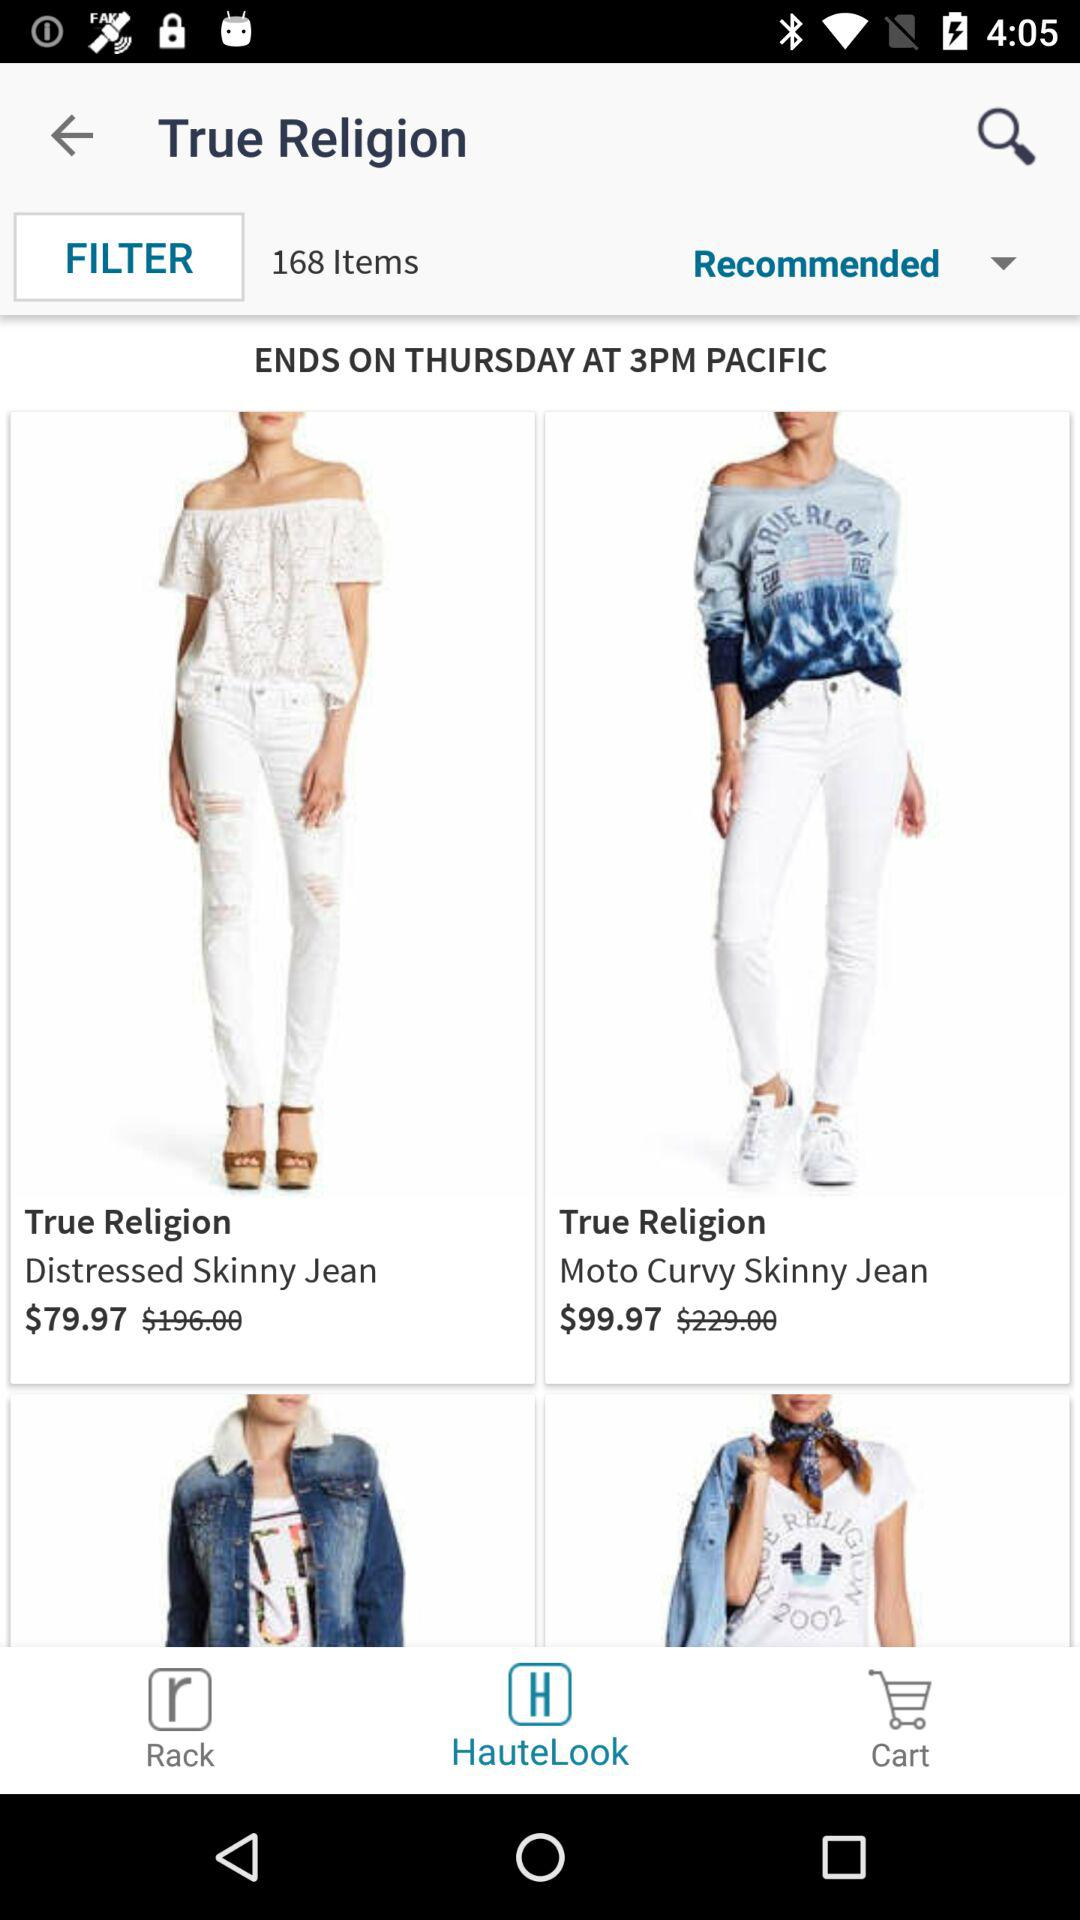What is the price of "Distressed Skinny Jean"? The price is $79.97. 